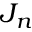<formula> <loc_0><loc_0><loc_500><loc_500>J _ { n }</formula> 